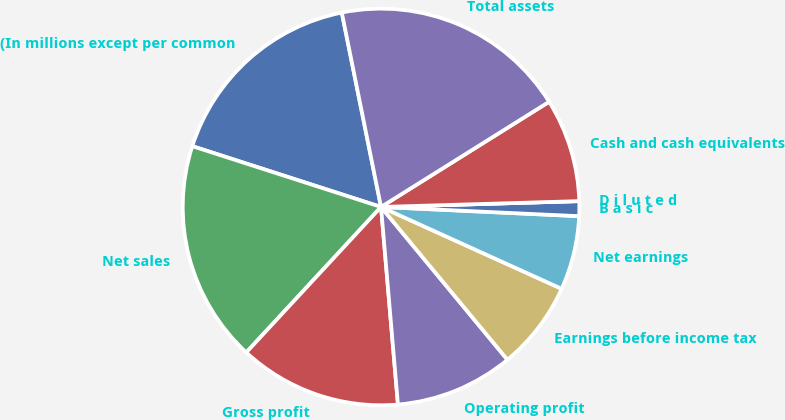Convert chart. <chart><loc_0><loc_0><loc_500><loc_500><pie_chart><fcel>(In millions except per common<fcel>Net sales<fcel>Gross profit<fcel>Operating profit<fcel>Earnings before income tax<fcel>Net earnings<fcel>B a s i c<fcel>D i l u t e d<fcel>Cash and cash equivalents<fcel>Total assets<nl><fcel>16.87%<fcel>18.07%<fcel>13.25%<fcel>9.64%<fcel>7.23%<fcel>6.03%<fcel>1.21%<fcel>0.0%<fcel>8.43%<fcel>19.27%<nl></chart> 